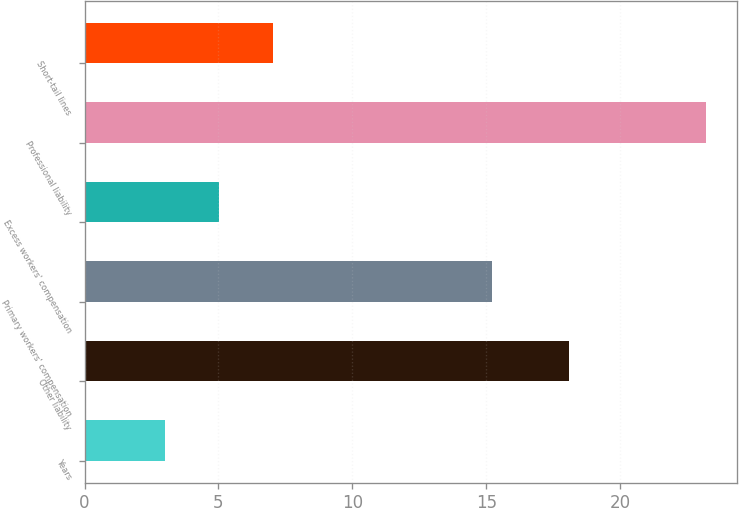Convert chart. <chart><loc_0><loc_0><loc_500><loc_500><bar_chart><fcel>Years<fcel>Other liability<fcel>Primary workers' compensation<fcel>Excess workers' compensation<fcel>Professional liability<fcel>Short-tail lines<nl><fcel>3<fcel>18.1<fcel>15.2<fcel>5.02<fcel>23.2<fcel>7.04<nl></chart> 